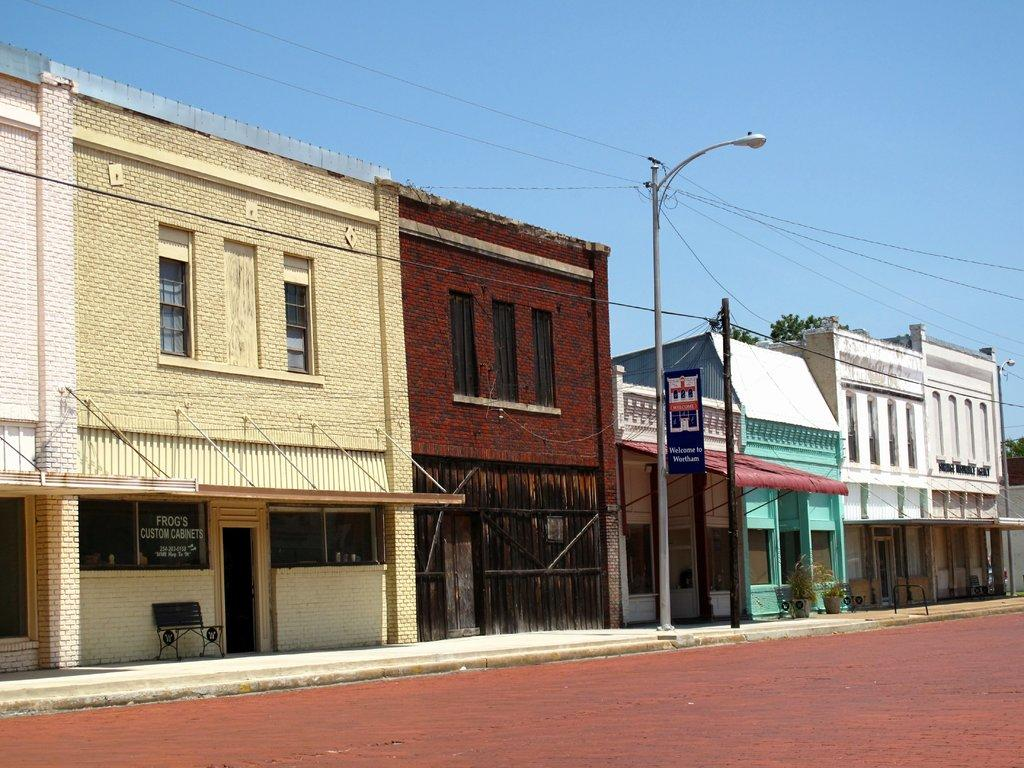What is in the foreground of the image? There is a road in the foreground of the image. What can be seen in the middle of the image? There are buildings and poles in the middle of the image. What is visible at the top of the image? The sky is visible at the top of the image. What time is displayed on the clock in the image? There is no clock present in the image. Can you see a plane flying in the sky in the image? There is no plane visible in the sky in the image. 